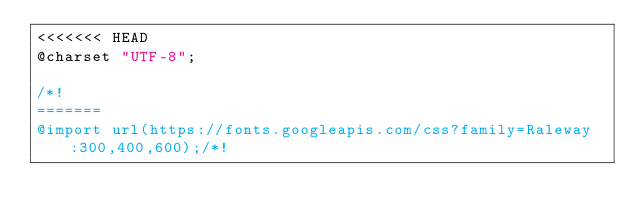Convert code to text. <code><loc_0><loc_0><loc_500><loc_500><_CSS_><<<<<<< HEAD
@charset "UTF-8";

/*!
=======
@import url(https://fonts.googleapis.com/css?family=Raleway:300,400,600);/*!</code> 